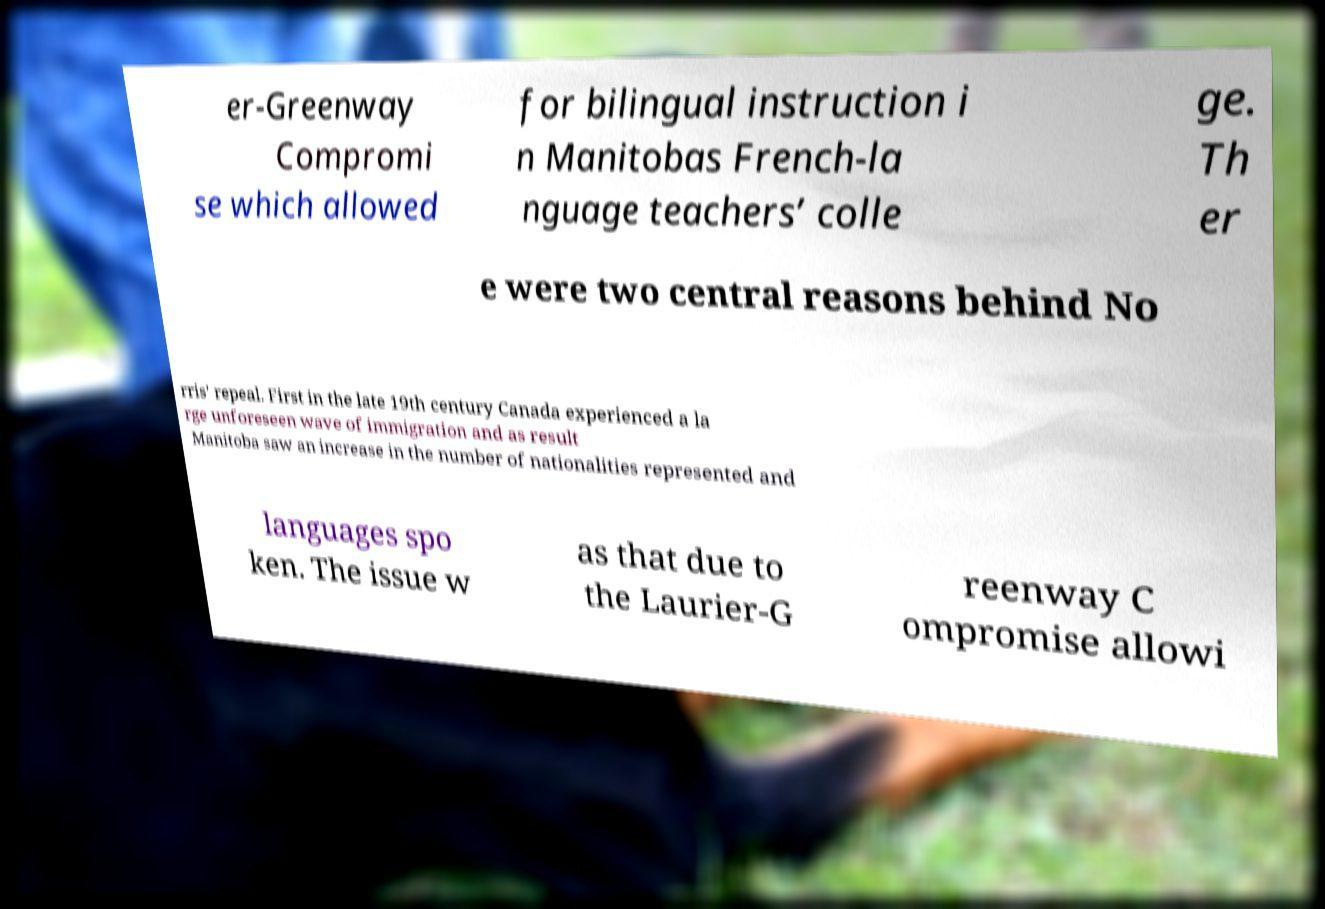For documentation purposes, I need the text within this image transcribed. Could you provide that? er-Greenway Compromi se which allowed for bilingual instruction i n Manitobas French-la nguage teachers’ colle ge. Th er e were two central reasons behind No rris' repeal. First in the late 19th century Canada experienced a la rge unforeseen wave of immigration and as result Manitoba saw an increase in the number of nationalities represented and languages spo ken. The issue w as that due to the Laurier-G reenway C ompromise allowi 